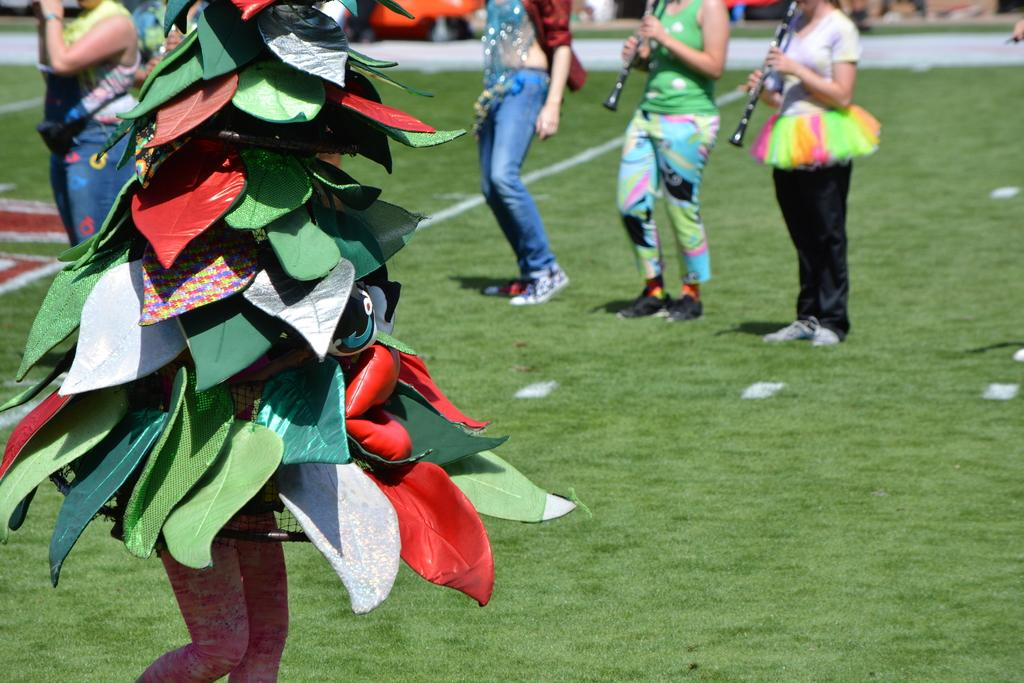How many people are in the image? There is a group of people standing in the image. What is the person in front wearing? The person in front is wearing a colorful dress. What can be seen in the background of the image? There is an object with an orange color and grass with a green color in the background. What type of pin can be seen holding the person's dress together in the image? There is no pin visible in the image; the person is wearing a dress without any visible pins. 